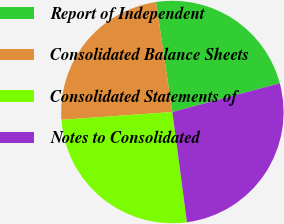Convert chart to OTSL. <chart><loc_0><loc_0><loc_500><loc_500><pie_chart><fcel>Report of Independent<fcel>Consolidated Balance Sheets<fcel>Consolidated Statements of<fcel>Notes to Consolidated<nl><fcel>23.2%<fcel>23.76%<fcel>25.97%<fcel>27.07%<nl></chart> 